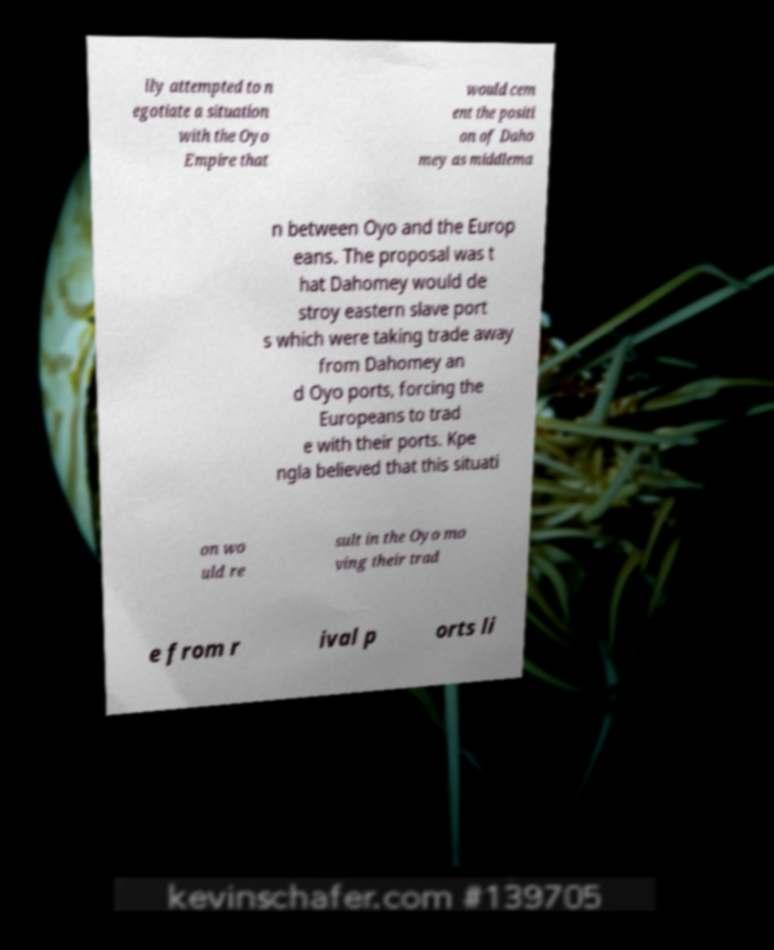Can you read and provide the text displayed in the image?This photo seems to have some interesting text. Can you extract and type it out for me? lly attempted to n egotiate a situation with the Oyo Empire that would cem ent the positi on of Daho mey as middlema n between Oyo and the Europ eans. The proposal was t hat Dahomey would de stroy eastern slave port s which were taking trade away from Dahomey an d Oyo ports, forcing the Europeans to trad e with their ports. Kpe ngla believed that this situati on wo uld re sult in the Oyo mo ving their trad e from r ival p orts li 